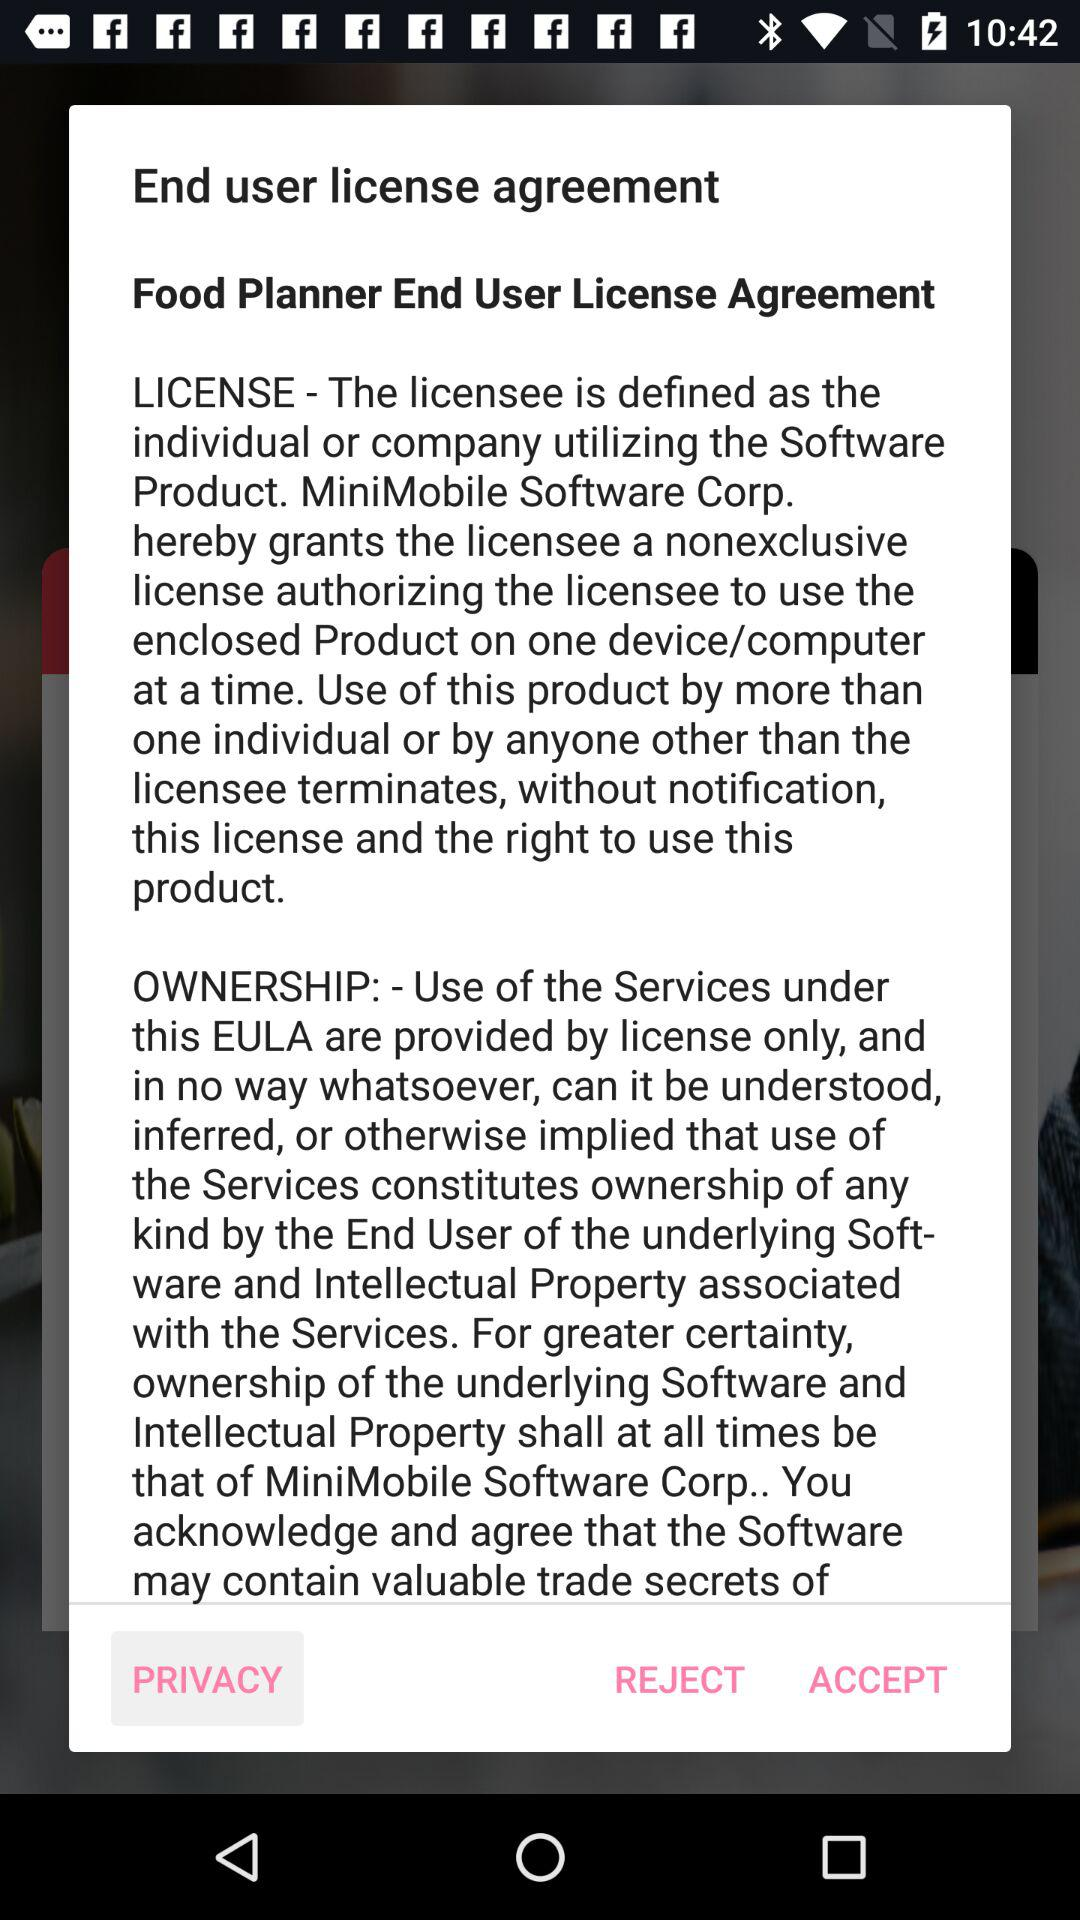What is the full form of EULA? The full form of EULA is "End user license agreement". 